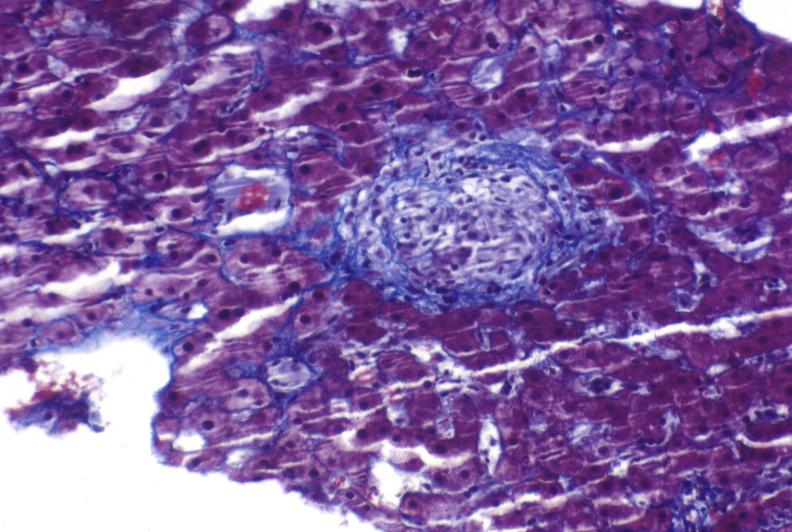does postpartum show sarcoid?
Answer the question using a single word or phrase. No 